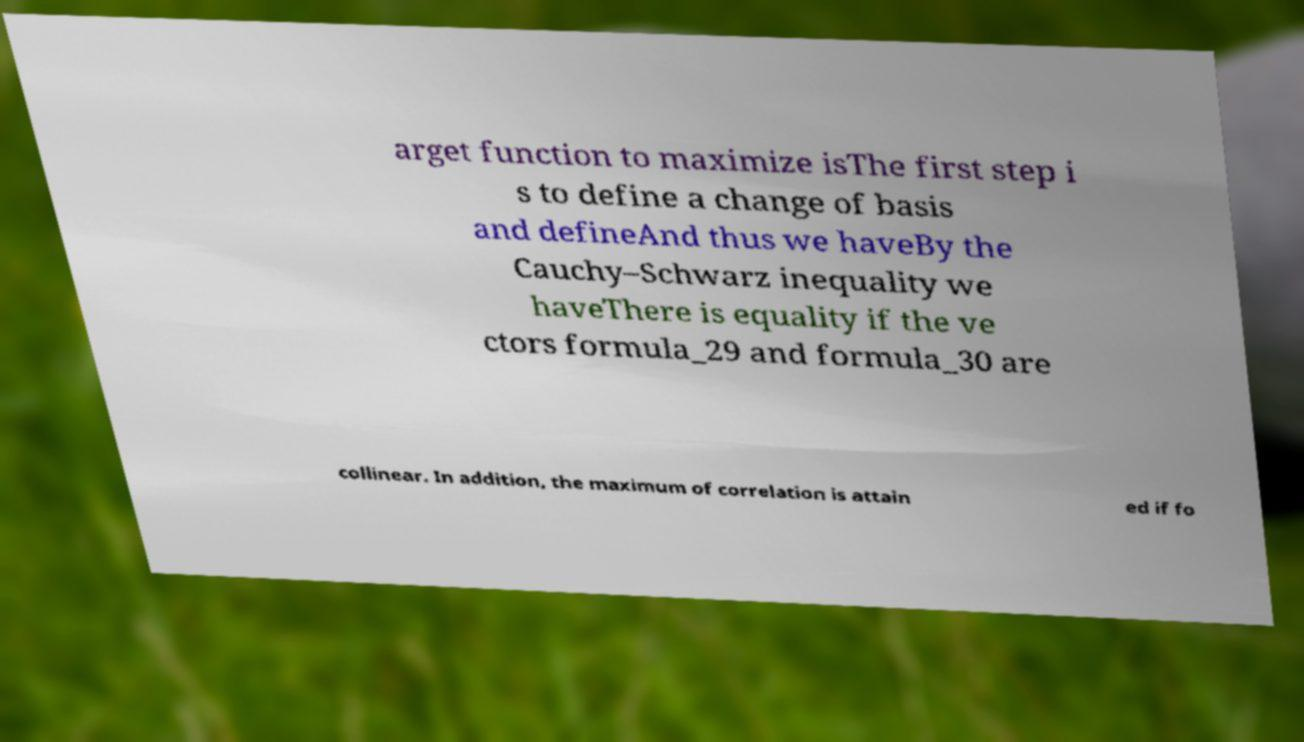There's text embedded in this image that I need extracted. Can you transcribe it verbatim? arget function to maximize isThe first step i s to define a change of basis and defineAnd thus we haveBy the Cauchy–Schwarz inequality we haveThere is equality if the ve ctors formula_29 and formula_30 are collinear. In addition, the maximum of correlation is attain ed if fo 